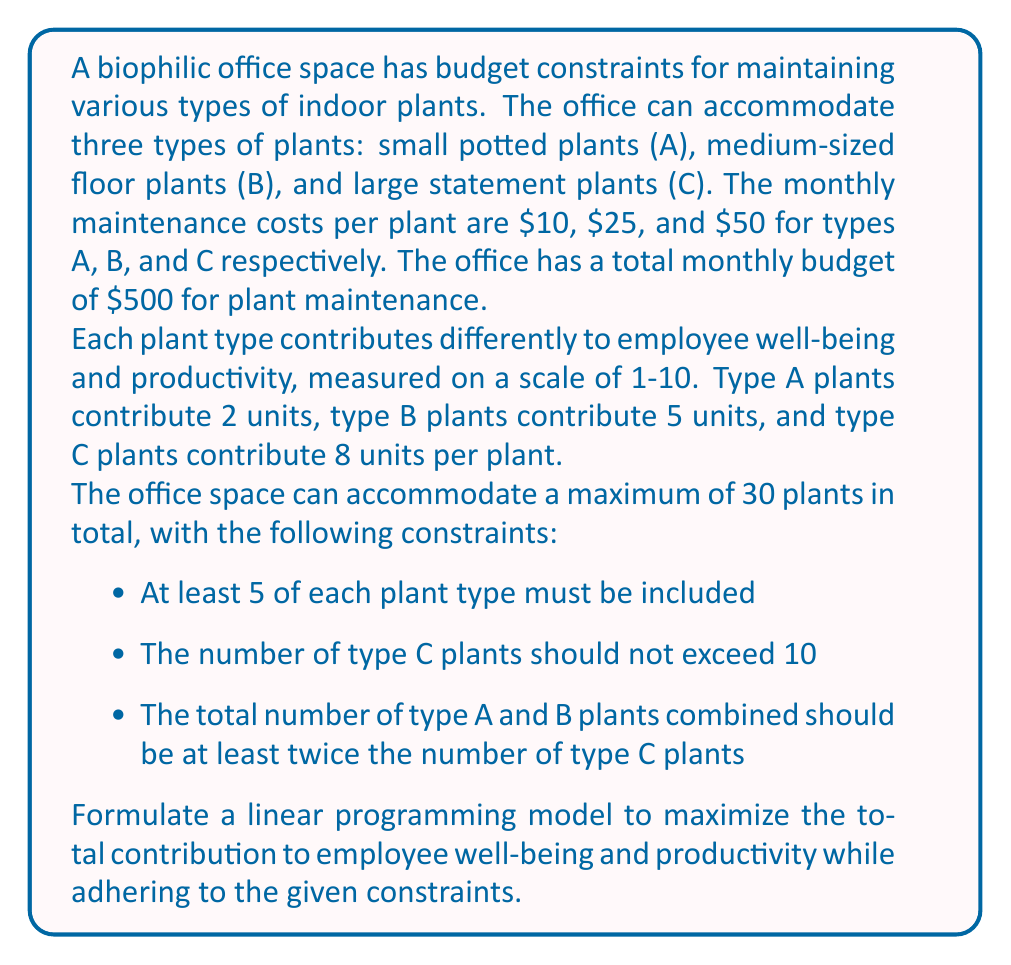Help me with this question. To formulate this linear programming model, we need to define our decision variables, objective function, and constraints.

Decision variables:
Let $x_A$, $x_B$, and $x_C$ represent the number of plants of type A, B, and C, respectively.

Objective function:
Maximize the total contribution to employee well-being and productivity:
$$\text{Maximize } Z = 2x_A + 5x_B + 8x_C$$

Constraints:

1. Budget constraint:
   $$10x_A + 25x_B + 50x_C \leq 500$$

2. Total number of plants:
   $$x_A + x_B + x_C \leq 30$$

3. Minimum number of each plant type:
   $$x_A \geq 5$$
   $$x_B \geq 5$$
   $$x_C \geq 5$$

4. Maximum number of type C plants:
   $$x_C \leq 10$$

5. Relationship between A, B, and C plants:
   $$x_A + x_B \geq 2x_C$$

6. Non-negativity constraints:
   $$x_A, x_B, x_C \geq 0$$

7. Integer constraints (since we can't have fractional plants):
   $$x_A, x_B, x_C \in \mathbb{Z}$$

The complete linear programming model can be written as:

$$\begin{align*}
\text{Maximize } & Z = 2x_A + 5x_B + 8x_C \\
\text{Subject to: } & \\
& 10x_A + 25x_B + 50x_C \leq 500 \\
& x_A + x_B + x_C \leq 30 \\
& x_A \geq 5 \\
& x_B \geq 5 \\
& x_C \geq 5 \\
& x_C \leq 10 \\
& x_A + x_B \geq 2x_C \\
& x_A, x_B, x_C \geq 0 \\
& x_A, x_B, x_C \in \mathbb{Z}
\end{align*}$$

This model can be solved using integer linear programming techniques to find the optimal allocation of plants that maximizes employee well-being and productivity while satisfying all constraints.
Answer: The linear programming model to maximize the total contribution to employee well-being and productivity is:

$$\begin{align*}
\text{Maximize } & Z = 2x_A + 5x_B + 8x_C \\
\text{Subject to: } & \\
& 10x_A + 25x_B + 50x_C \leq 500 \\
& x_A + x_B + x_C \leq 30 \\
& x_A \geq 5 \\
& x_B \geq 5 \\
& x_C \geq 5 \\
& x_C \leq 10 \\
& x_A + x_B \geq 2x_C \\
& x_A, x_B, x_C \geq 0 \\
& x_A, x_B, x_C \in \mathbb{Z}
\end{align*}$$ 